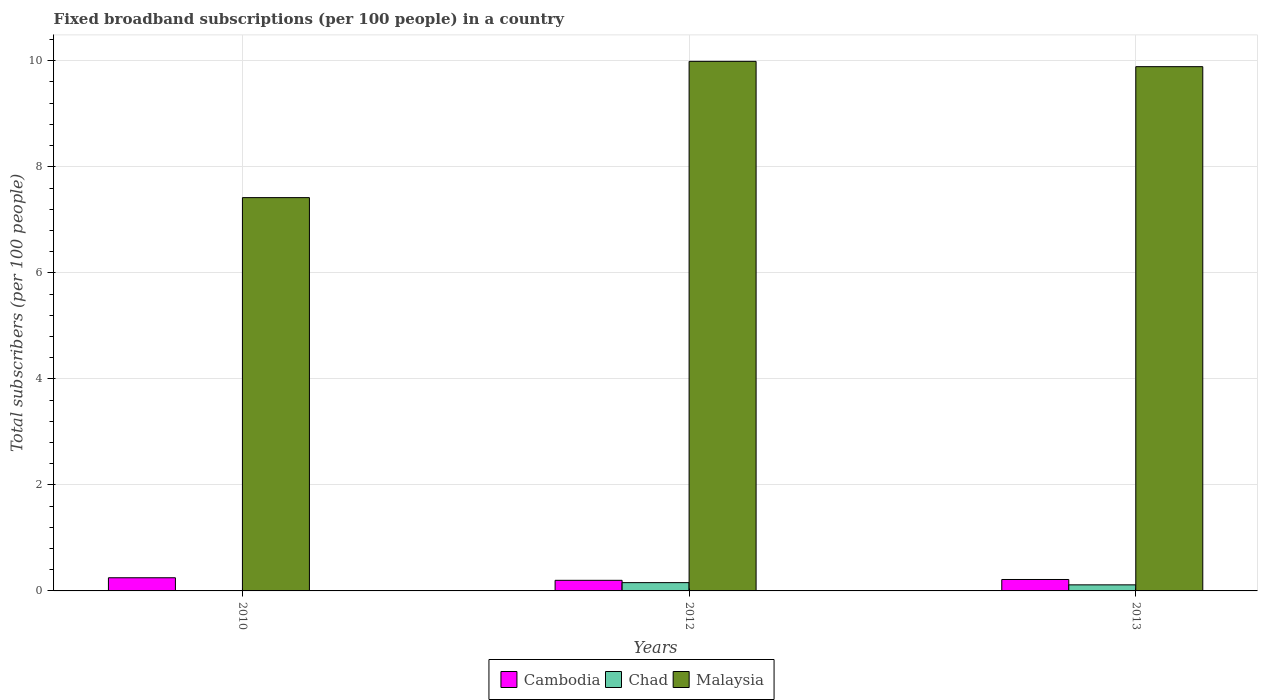How many different coloured bars are there?
Your answer should be very brief. 3. How many groups of bars are there?
Provide a succinct answer. 3. Are the number of bars per tick equal to the number of legend labels?
Offer a terse response. Yes. How many bars are there on the 2nd tick from the right?
Provide a succinct answer. 3. What is the label of the 1st group of bars from the left?
Provide a succinct answer. 2010. In how many cases, is the number of bars for a given year not equal to the number of legend labels?
Your answer should be compact. 0. What is the number of broadband subscriptions in Malaysia in 2010?
Offer a very short reply. 7.42. Across all years, what is the maximum number of broadband subscriptions in Cambodia?
Provide a short and direct response. 0.25. Across all years, what is the minimum number of broadband subscriptions in Chad?
Your answer should be compact. 0. What is the total number of broadband subscriptions in Malaysia in the graph?
Keep it short and to the point. 27.3. What is the difference between the number of broadband subscriptions in Cambodia in 2010 and that in 2013?
Keep it short and to the point. 0.03. What is the difference between the number of broadband subscriptions in Chad in 2010 and the number of broadband subscriptions in Malaysia in 2013?
Provide a succinct answer. -9.89. What is the average number of broadband subscriptions in Malaysia per year?
Offer a terse response. 9.1. In the year 2013, what is the difference between the number of broadband subscriptions in Cambodia and number of broadband subscriptions in Chad?
Offer a terse response. 0.1. What is the ratio of the number of broadband subscriptions in Chad in 2010 to that in 2012?
Offer a terse response. 0.02. Is the difference between the number of broadband subscriptions in Cambodia in 2010 and 2013 greater than the difference between the number of broadband subscriptions in Chad in 2010 and 2013?
Provide a succinct answer. Yes. What is the difference between the highest and the second highest number of broadband subscriptions in Malaysia?
Your response must be concise. 0.1. What is the difference between the highest and the lowest number of broadband subscriptions in Chad?
Provide a short and direct response. 0.15. In how many years, is the number of broadband subscriptions in Cambodia greater than the average number of broadband subscriptions in Cambodia taken over all years?
Keep it short and to the point. 1. What does the 3rd bar from the left in 2013 represents?
Give a very brief answer. Malaysia. What does the 3rd bar from the right in 2012 represents?
Your answer should be very brief. Cambodia. How many years are there in the graph?
Your response must be concise. 3. What is the difference between two consecutive major ticks on the Y-axis?
Your response must be concise. 2. Are the values on the major ticks of Y-axis written in scientific E-notation?
Your answer should be very brief. No. Does the graph contain grids?
Make the answer very short. Yes. Where does the legend appear in the graph?
Your answer should be very brief. Bottom center. What is the title of the graph?
Your answer should be compact. Fixed broadband subscriptions (per 100 people) in a country. Does "Moldova" appear as one of the legend labels in the graph?
Your answer should be very brief. No. What is the label or title of the X-axis?
Offer a terse response. Years. What is the label or title of the Y-axis?
Provide a short and direct response. Total subscribers (per 100 people). What is the Total subscribers (per 100 people) of Cambodia in 2010?
Offer a terse response. 0.25. What is the Total subscribers (per 100 people) of Chad in 2010?
Keep it short and to the point. 0. What is the Total subscribers (per 100 people) of Malaysia in 2010?
Keep it short and to the point. 7.42. What is the Total subscribers (per 100 people) of Cambodia in 2012?
Your answer should be compact. 0.2. What is the Total subscribers (per 100 people) of Chad in 2012?
Your answer should be compact. 0.16. What is the Total subscribers (per 100 people) of Malaysia in 2012?
Provide a succinct answer. 9.99. What is the Total subscribers (per 100 people) of Cambodia in 2013?
Your answer should be very brief. 0.22. What is the Total subscribers (per 100 people) of Chad in 2013?
Ensure brevity in your answer.  0.11. What is the Total subscribers (per 100 people) in Malaysia in 2013?
Give a very brief answer. 9.89. Across all years, what is the maximum Total subscribers (per 100 people) of Cambodia?
Provide a short and direct response. 0.25. Across all years, what is the maximum Total subscribers (per 100 people) of Chad?
Keep it short and to the point. 0.16. Across all years, what is the maximum Total subscribers (per 100 people) of Malaysia?
Ensure brevity in your answer.  9.99. Across all years, what is the minimum Total subscribers (per 100 people) of Cambodia?
Ensure brevity in your answer.  0.2. Across all years, what is the minimum Total subscribers (per 100 people) in Chad?
Keep it short and to the point. 0. Across all years, what is the minimum Total subscribers (per 100 people) in Malaysia?
Offer a terse response. 7.42. What is the total Total subscribers (per 100 people) of Cambodia in the graph?
Ensure brevity in your answer.  0.66. What is the total Total subscribers (per 100 people) of Chad in the graph?
Your response must be concise. 0.27. What is the total Total subscribers (per 100 people) in Malaysia in the graph?
Your answer should be compact. 27.3. What is the difference between the Total subscribers (per 100 people) in Cambodia in 2010 and that in 2012?
Offer a very short reply. 0.05. What is the difference between the Total subscribers (per 100 people) of Chad in 2010 and that in 2012?
Your answer should be compact. -0.15. What is the difference between the Total subscribers (per 100 people) of Malaysia in 2010 and that in 2012?
Keep it short and to the point. -2.57. What is the difference between the Total subscribers (per 100 people) of Cambodia in 2010 and that in 2013?
Your response must be concise. 0.03. What is the difference between the Total subscribers (per 100 people) of Chad in 2010 and that in 2013?
Your answer should be compact. -0.11. What is the difference between the Total subscribers (per 100 people) in Malaysia in 2010 and that in 2013?
Your response must be concise. -2.47. What is the difference between the Total subscribers (per 100 people) in Cambodia in 2012 and that in 2013?
Ensure brevity in your answer.  -0.02. What is the difference between the Total subscribers (per 100 people) in Chad in 2012 and that in 2013?
Give a very brief answer. 0.04. What is the difference between the Total subscribers (per 100 people) in Malaysia in 2012 and that in 2013?
Give a very brief answer. 0.1. What is the difference between the Total subscribers (per 100 people) of Cambodia in 2010 and the Total subscribers (per 100 people) of Chad in 2012?
Provide a short and direct response. 0.09. What is the difference between the Total subscribers (per 100 people) in Cambodia in 2010 and the Total subscribers (per 100 people) in Malaysia in 2012?
Your answer should be very brief. -9.74. What is the difference between the Total subscribers (per 100 people) of Chad in 2010 and the Total subscribers (per 100 people) of Malaysia in 2012?
Offer a very short reply. -9.99. What is the difference between the Total subscribers (per 100 people) in Cambodia in 2010 and the Total subscribers (per 100 people) in Chad in 2013?
Your response must be concise. 0.13. What is the difference between the Total subscribers (per 100 people) in Cambodia in 2010 and the Total subscribers (per 100 people) in Malaysia in 2013?
Your answer should be very brief. -9.64. What is the difference between the Total subscribers (per 100 people) in Chad in 2010 and the Total subscribers (per 100 people) in Malaysia in 2013?
Give a very brief answer. -9.89. What is the difference between the Total subscribers (per 100 people) in Cambodia in 2012 and the Total subscribers (per 100 people) in Chad in 2013?
Offer a very short reply. 0.09. What is the difference between the Total subscribers (per 100 people) of Cambodia in 2012 and the Total subscribers (per 100 people) of Malaysia in 2013?
Your answer should be compact. -9.69. What is the difference between the Total subscribers (per 100 people) of Chad in 2012 and the Total subscribers (per 100 people) of Malaysia in 2013?
Offer a very short reply. -9.73. What is the average Total subscribers (per 100 people) in Cambodia per year?
Provide a short and direct response. 0.22. What is the average Total subscribers (per 100 people) of Chad per year?
Offer a very short reply. 0.09. What is the average Total subscribers (per 100 people) of Malaysia per year?
Keep it short and to the point. 9.1. In the year 2010, what is the difference between the Total subscribers (per 100 people) of Cambodia and Total subscribers (per 100 people) of Chad?
Your answer should be very brief. 0.25. In the year 2010, what is the difference between the Total subscribers (per 100 people) in Cambodia and Total subscribers (per 100 people) in Malaysia?
Your answer should be very brief. -7.17. In the year 2010, what is the difference between the Total subscribers (per 100 people) of Chad and Total subscribers (per 100 people) of Malaysia?
Ensure brevity in your answer.  -7.42. In the year 2012, what is the difference between the Total subscribers (per 100 people) of Cambodia and Total subscribers (per 100 people) of Chad?
Provide a succinct answer. 0.04. In the year 2012, what is the difference between the Total subscribers (per 100 people) in Cambodia and Total subscribers (per 100 people) in Malaysia?
Provide a short and direct response. -9.79. In the year 2012, what is the difference between the Total subscribers (per 100 people) in Chad and Total subscribers (per 100 people) in Malaysia?
Ensure brevity in your answer.  -9.83. In the year 2013, what is the difference between the Total subscribers (per 100 people) in Cambodia and Total subscribers (per 100 people) in Chad?
Offer a very short reply. 0.1. In the year 2013, what is the difference between the Total subscribers (per 100 people) of Cambodia and Total subscribers (per 100 people) of Malaysia?
Your answer should be very brief. -9.67. In the year 2013, what is the difference between the Total subscribers (per 100 people) in Chad and Total subscribers (per 100 people) in Malaysia?
Make the answer very short. -9.77. What is the ratio of the Total subscribers (per 100 people) in Cambodia in 2010 to that in 2012?
Provide a short and direct response. 1.24. What is the ratio of the Total subscribers (per 100 people) in Chad in 2010 to that in 2012?
Make the answer very short. 0.02. What is the ratio of the Total subscribers (per 100 people) of Malaysia in 2010 to that in 2012?
Provide a succinct answer. 0.74. What is the ratio of the Total subscribers (per 100 people) in Cambodia in 2010 to that in 2013?
Your response must be concise. 1.15. What is the ratio of the Total subscribers (per 100 people) in Chad in 2010 to that in 2013?
Provide a succinct answer. 0.02. What is the ratio of the Total subscribers (per 100 people) of Malaysia in 2010 to that in 2013?
Your answer should be very brief. 0.75. What is the ratio of the Total subscribers (per 100 people) in Cambodia in 2012 to that in 2013?
Make the answer very short. 0.93. What is the ratio of the Total subscribers (per 100 people) in Chad in 2012 to that in 2013?
Provide a succinct answer. 1.36. What is the difference between the highest and the second highest Total subscribers (per 100 people) in Cambodia?
Provide a succinct answer. 0.03. What is the difference between the highest and the second highest Total subscribers (per 100 people) of Chad?
Offer a very short reply. 0.04. What is the difference between the highest and the second highest Total subscribers (per 100 people) of Malaysia?
Ensure brevity in your answer.  0.1. What is the difference between the highest and the lowest Total subscribers (per 100 people) of Cambodia?
Keep it short and to the point. 0.05. What is the difference between the highest and the lowest Total subscribers (per 100 people) of Chad?
Give a very brief answer. 0.15. What is the difference between the highest and the lowest Total subscribers (per 100 people) of Malaysia?
Your answer should be compact. 2.57. 